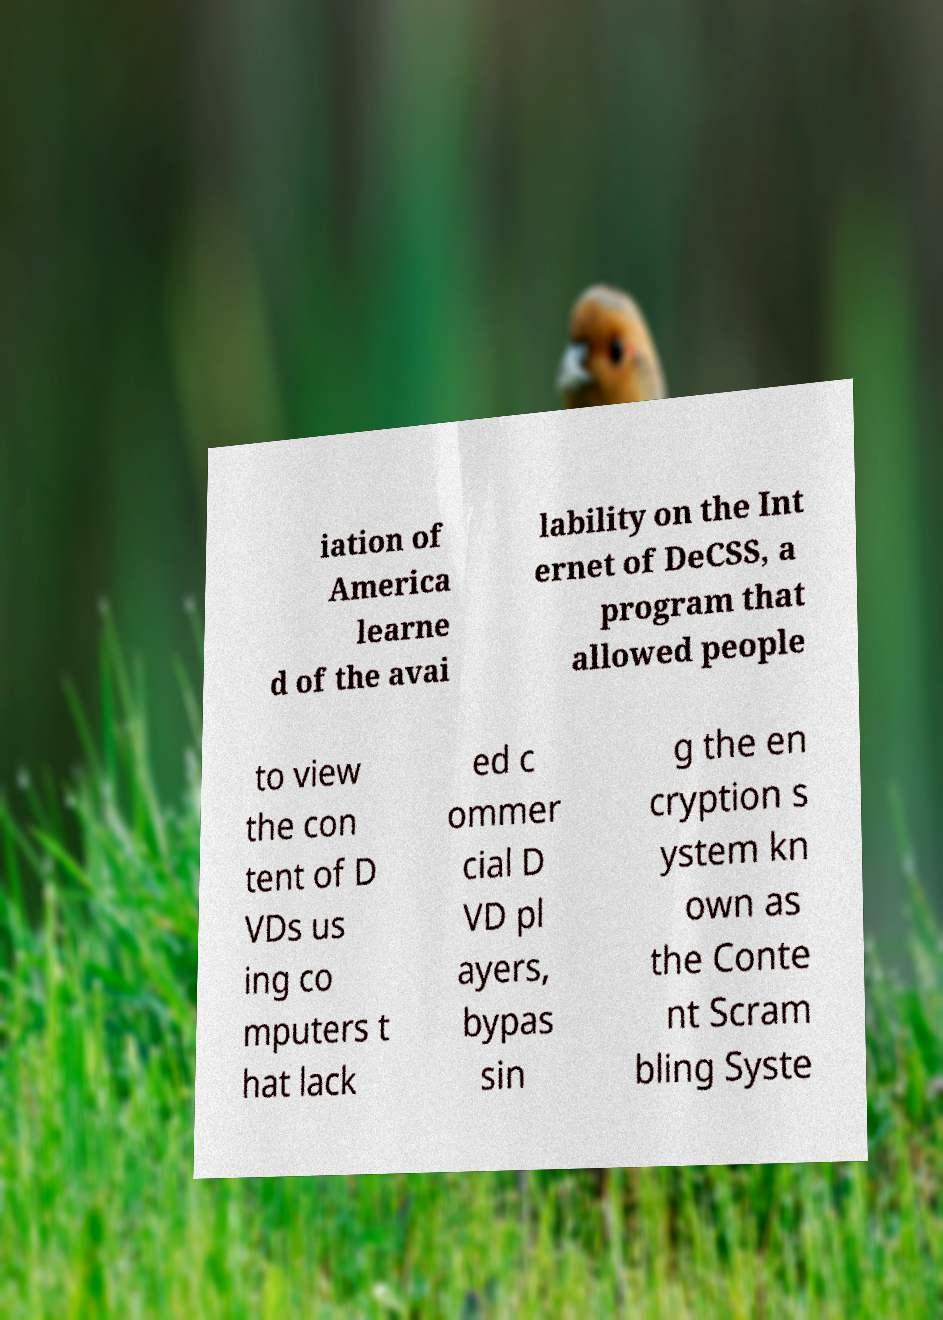Can you accurately transcribe the text from the provided image for me? iation of America learne d of the avai lability on the Int ernet of DeCSS, a program that allowed people to view the con tent of D VDs us ing co mputers t hat lack ed c ommer cial D VD pl ayers, bypas sin g the en cryption s ystem kn own as the Conte nt Scram bling Syste 